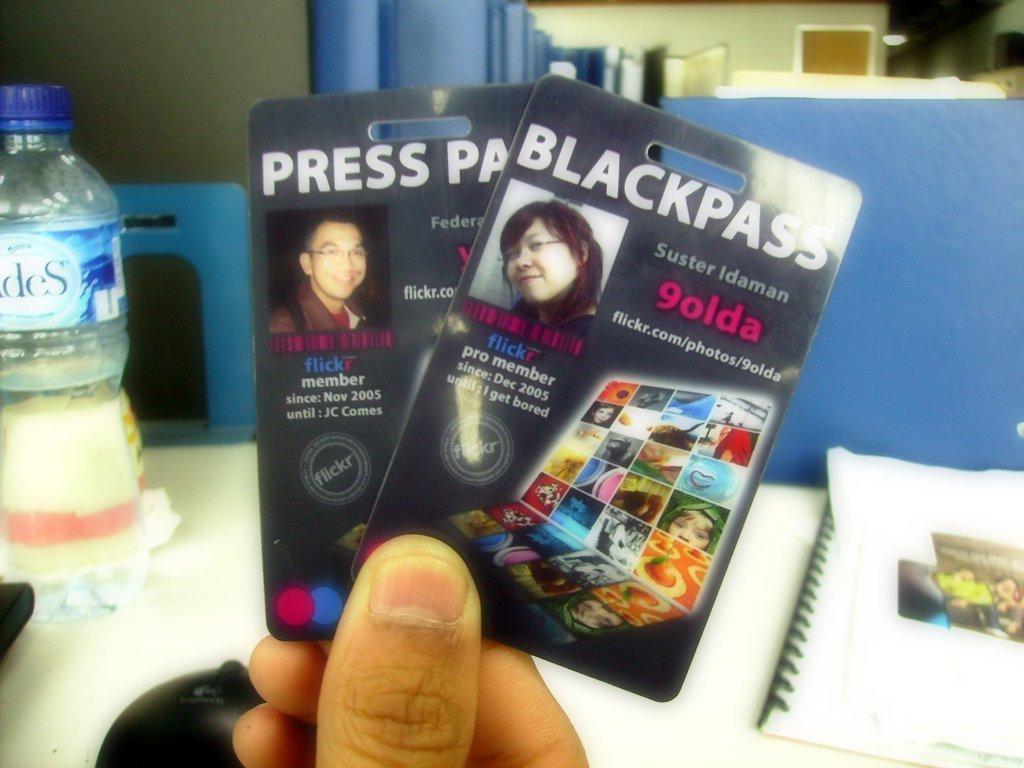Can you describe this image briefly? In the picture we can see a fingers holding a two packs, near the table, on the table we can find a bottle, paper, with binding. In the background we can see a door, wall, which is blue in color. 